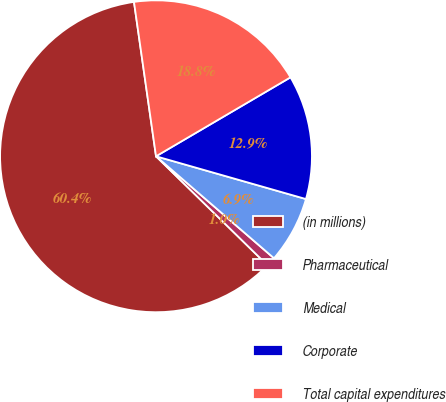<chart> <loc_0><loc_0><loc_500><loc_500><pie_chart><fcel>(in millions)<fcel>Pharmaceutical<fcel>Medical<fcel>Corporate<fcel>Total capital expenditures<nl><fcel>60.42%<fcel>0.98%<fcel>6.92%<fcel>12.87%<fcel>18.81%<nl></chart> 